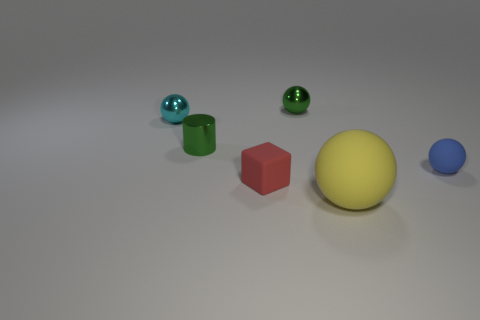How many other objects are the same color as the cylinder? Including the green cylinder, there are three objects that share the same vibrant green color. Each of the other items in the image—like the yellow sphere, blue capsule, and red cube—feature distinct colors, setting them apart from the green-colored objects. 